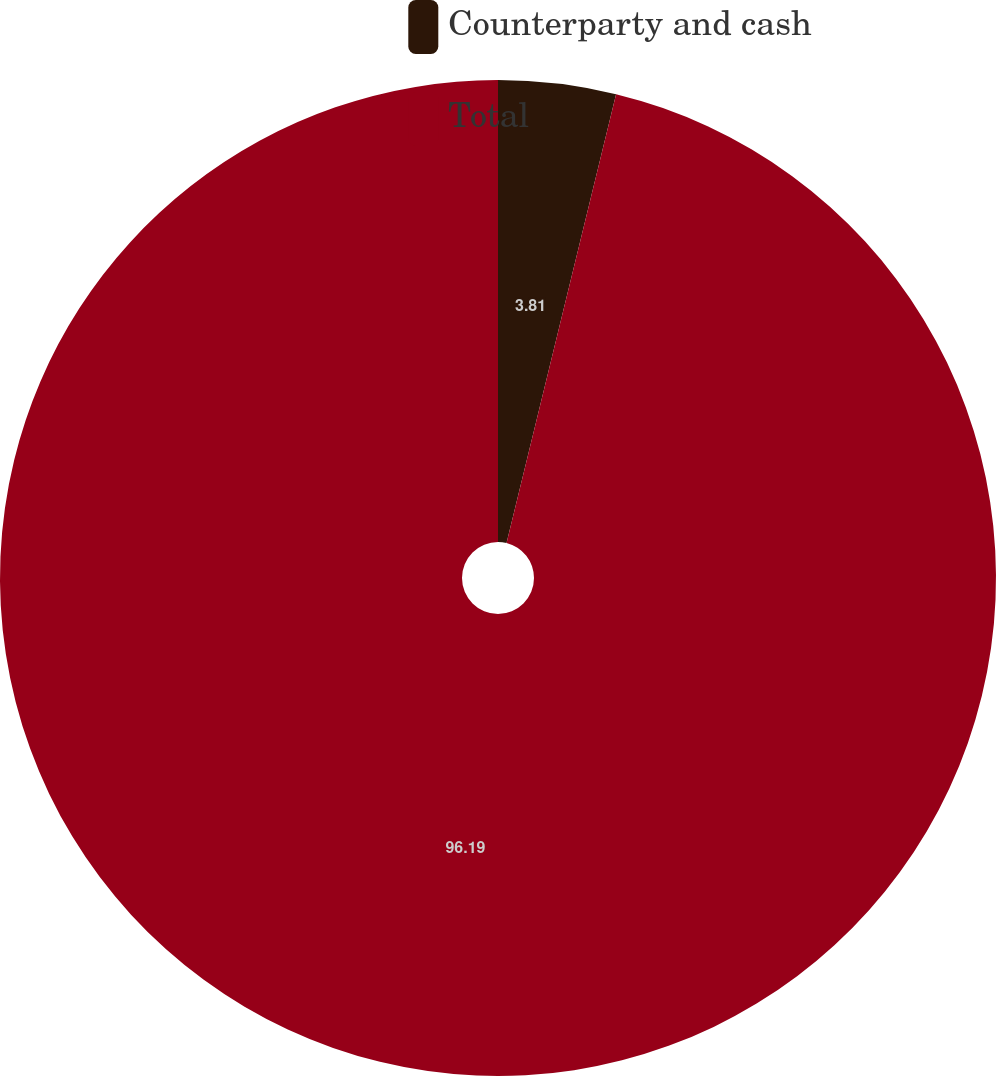Convert chart. <chart><loc_0><loc_0><loc_500><loc_500><pie_chart><fcel>Counterparty and cash<fcel>Total<nl><fcel>3.81%<fcel>96.19%<nl></chart> 